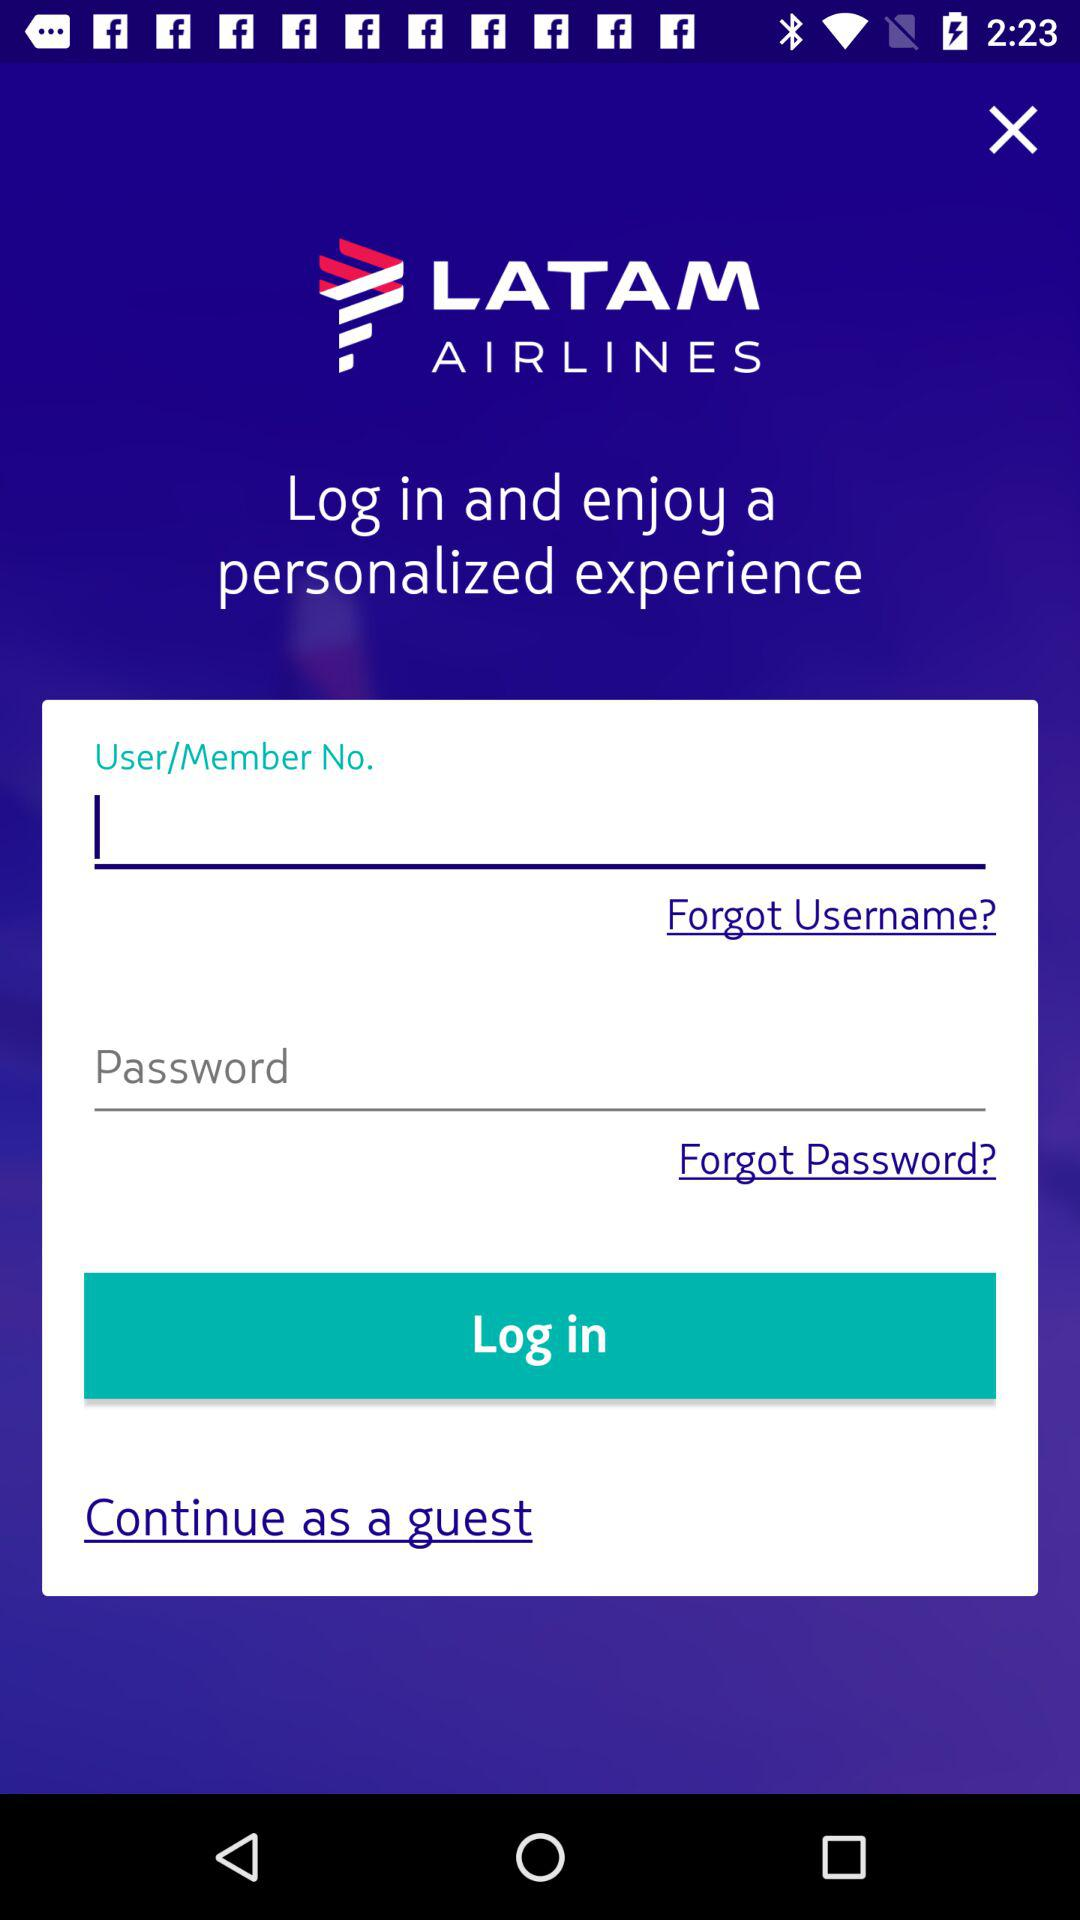Can we reset username?
When the provided information is insufficient, respond with <no answer>. <no answer> 